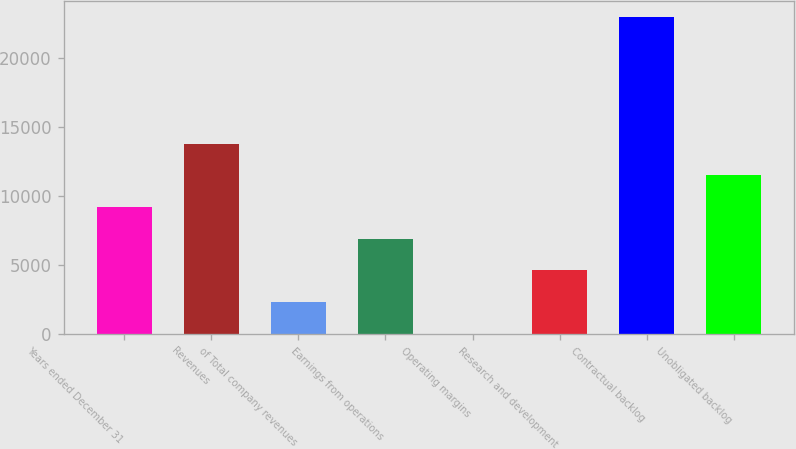Convert chart. <chart><loc_0><loc_0><loc_500><loc_500><bar_chart><fcel>Years ended December 31<fcel>Revenues<fcel>of Total company revenues<fcel>Earnings from operations<fcel>Operating margins<fcel>Research and development<fcel>Contractual backlog<fcel>Unobligated backlog<nl><fcel>9196.74<fcel>13789.2<fcel>2308.11<fcel>6900.53<fcel>11.9<fcel>4604.32<fcel>22974<fcel>11493<nl></chart> 